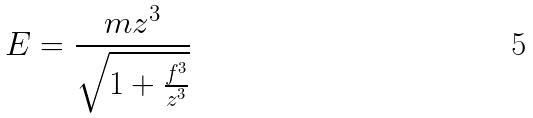Convert formula to latex. <formula><loc_0><loc_0><loc_500><loc_500>E = \frac { m z ^ { 3 } } { \sqrt { 1 + \frac { f ^ { 3 } } { z ^ { 3 } } } }</formula> 